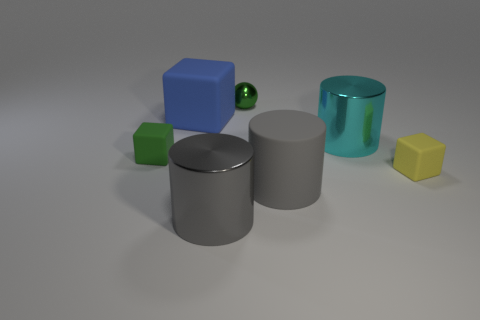What number of other things are the same color as the large rubber cylinder?
Your answer should be very brief. 1. There is a object that is behind the large cyan metal cylinder and on the left side of the green ball; what is its size?
Ensure brevity in your answer.  Large. What number of objects are things that are in front of the tiny yellow rubber thing or small yellow blocks?
Make the answer very short. 3. What shape is the small green thing that is made of the same material as the big cyan object?
Your answer should be very brief. Sphere. What is the shape of the gray shiny thing?
Your response must be concise. Cylinder. What color is the metallic thing that is behind the gray metal cylinder and on the left side of the large cyan metallic cylinder?
Give a very brief answer. Green. The matte thing that is the same size as the yellow rubber cube is what shape?
Give a very brief answer. Cube. Is there a small cyan thing of the same shape as the yellow thing?
Offer a terse response. No. Are the cyan object and the gray cylinder that is behind the big gray shiny cylinder made of the same material?
Offer a terse response. No. What color is the rubber block that is left of the large rubber object behind the green object in front of the blue matte thing?
Ensure brevity in your answer.  Green. 